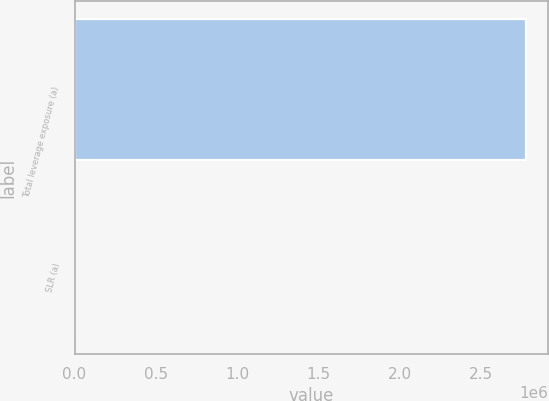<chart> <loc_0><loc_0><loc_500><loc_500><bar_chart><fcel>Total leverage exposure (a)<fcel>SLR (a)<nl><fcel>2.77504e+06<fcel>6.6<nl></chart> 